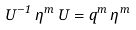Convert formula to latex. <formula><loc_0><loc_0><loc_500><loc_500>U ^ { - 1 } \, \eta ^ { m } \, U = q ^ { m } \, \eta ^ { m }</formula> 